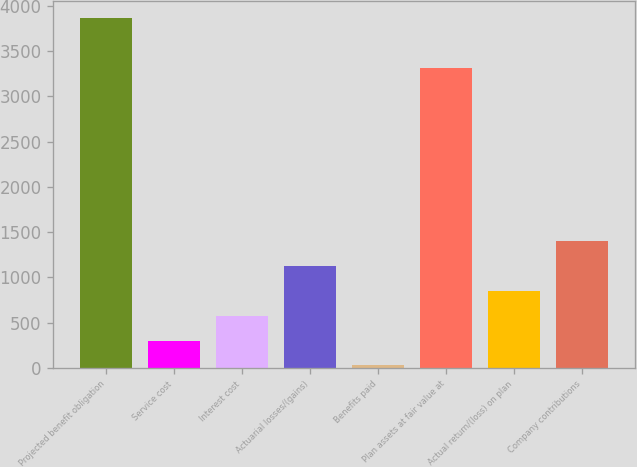Convert chart to OTSL. <chart><loc_0><loc_0><loc_500><loc_500><bar_chart><fcel>Projected benefit obligation<fcel>Service cost<fcel>Interest cost<fcel>Actuarial losses/(gains)<fcel>Benefits paid<fcel>Plan assets at fair value at<fcel>Actual return/(loss) on plan<fcel>Company contributions<nl><fcel>3862.6<fcel>301.9<fcel>575.8<fcel>1123.6<fcel>28<fcel>3314.8<fcel>849.7<fcel>1397.5<nl></chart> 